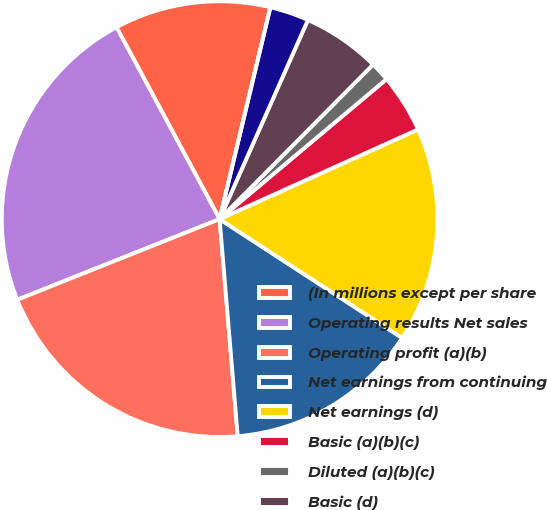Convert chart to OTSL. <chart><loc_0><loc_0><loc_500><loc_500><pie_chart><fcel>(In millions except per share<fcel>Operating results Net sales<fcel>Operating profit (a)(b)<fcel>Net earnings from continuing<fcel>Net earnings (d)<fcel>Basic (a)(b)(c)<fcel>Diluted (a)(b)(c)<fcel>Basic (d)<fcel>Diluted (d)<fcel>Cash dividends declared per<nl><fcel>11.59%<fcel>23.19%<fcel>20.29%<fcel>14.49%<fcel>15.94%<fcel>4.35%<fcel>1.45%<fcel>5.8%<fcel>2.9%<fcel>0.0%<nl></chart> 